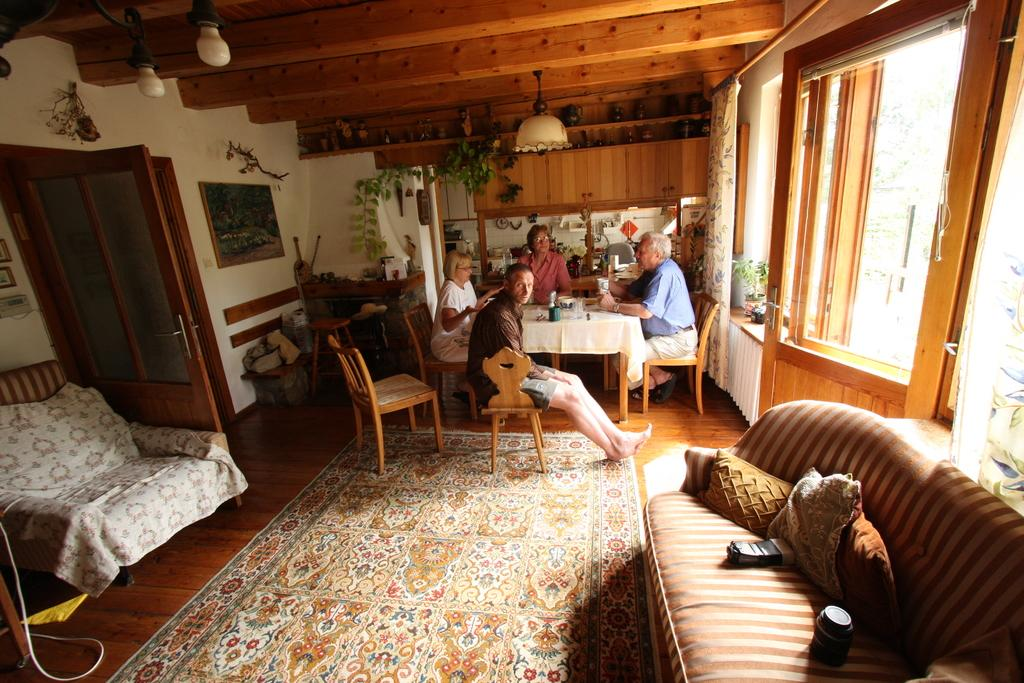How many people are sitting in the image? There are four people sitting on chairs in the image. What else can be seen in the image besides the people sitting on chairs? There is a couch pillow and a glass on a table in the image. How many pins are holding the shoe in the image? There is no shoe or pins present in the image. 